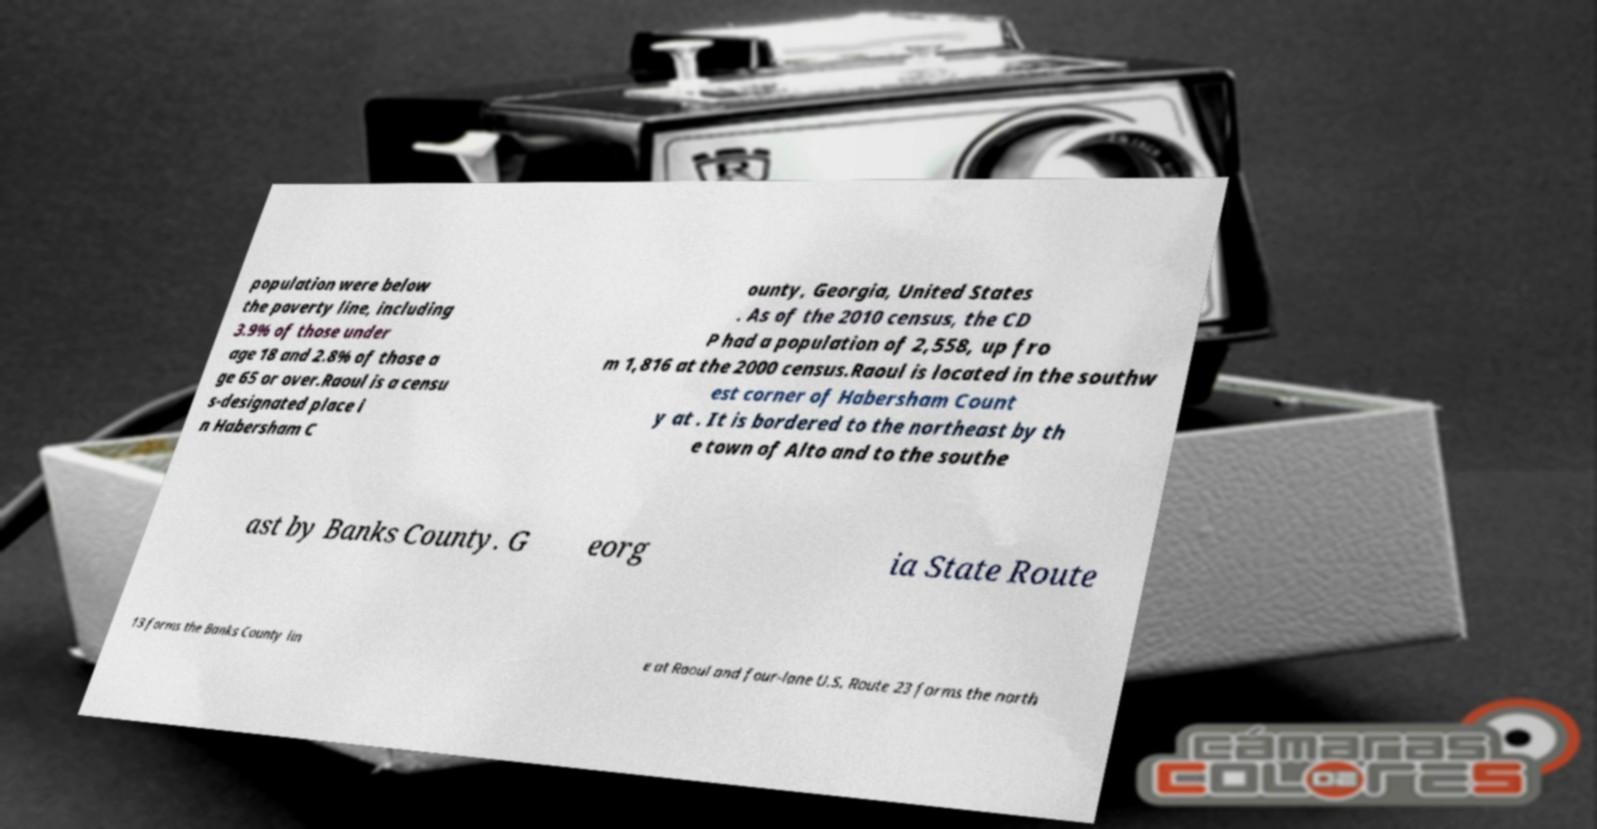For documentation purposes, I need the text within this image transcribed. Could you provide that? population were below the poverty line, including 3.9% of those under age 18 and 2.8% of those a ge 65 or over.Raoul is a censu s-designated place i n Habersham C ounty, Georgia, United States . As of the 2010 census, the CD P had a population of 2,558, up fro m 1,816 at the 2000 census.Raoul is located in the southw est corner of Habersham Count y at . It is bordered to the northeast by th e town of Alto and to the southe ast by Banks County. G eorg ia State Route 13 forms the Banks County lin e at Raoul and four-lane U.S. Route 23 forms the north 